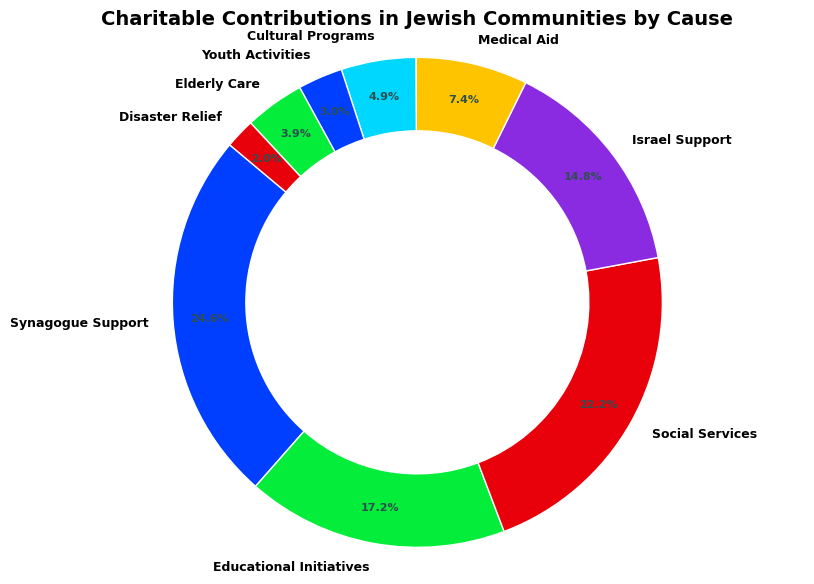Which category receives the highest amount of contributions? To determine the category with the highest amount, observe the largest wedge in the ring chart, which should visibly stand out.
Answer: Synagogue Support How much more is contributed to Social Services compared to Medical Aid? First, find the amounts for Social Services and Medical Aid. Then, subtract the amount of Medical Aid from the amount for Social Services: 225,000 - 75,000.
Answer: 150,000 What percentage of donations go to Educational Initiatives and Israel Support combined? Determine the percentages for both categories individually from the chart and then add them together.
Answer: 38.1% Is the amount contributed to Youth Activities greater than Elderly Care? Compare the visual size of the wedges for Youth Activities and Elderly Care. Alternatively, compare amounts directly: 30,000 for Youth Activities and 40,000 for Elderly Care.
Answer: No How does the contribution to Israel Support compare to Synagogue Support? Compare the visual size of the wedges or the numerical amounts directly. Synagogue Support is 250,000, and Israel Support is 150,000, so Synagogue Support is significantly higher.
Answer: Synagogue Support is greater Which cause has the smallest contribution? Identify the smallest wedge in the ring chart, which corresponds to Disaster Relief, with an amount of 20,000.
Answer: Disaster Relief What is the combined amount contributed to Educational Initiatives, Social Services, and Cultural Programs? Sum the amounts for these three categories: 175,000 for Educational Initiatives, 225,000 for Social Services, and 50,000 for Cultural Programs. 175,000 + 225,000 + 50,000 = 450,000.
Answer: 450,000 What is the visual difference in size between the categories Elderly Care and Disaster Relief? Compare the sizes of the two wedges in the ring chart. Elderly Care has a slightly larger wedge than Disaster Relief, indicating a larger contribution amount.
Answer: Elderly Care is larger Which categories receive a contribution amount less than 50,000? Look for wedges smaller than the wedge corresponding to 50,000. These should be Youth Activities and Disaster Relief.
Answer: Youth Activities, Disaster Relief How does the total contribution to Medical Aid and Cultural Programs compare to Social Services? Add the amounts for Medical Aid and Cultural Programs: 75,000 + 50,000 = 125,000, then compare this to the amount for Social Services, which is 225,000.
Answer: Social Services is greater 